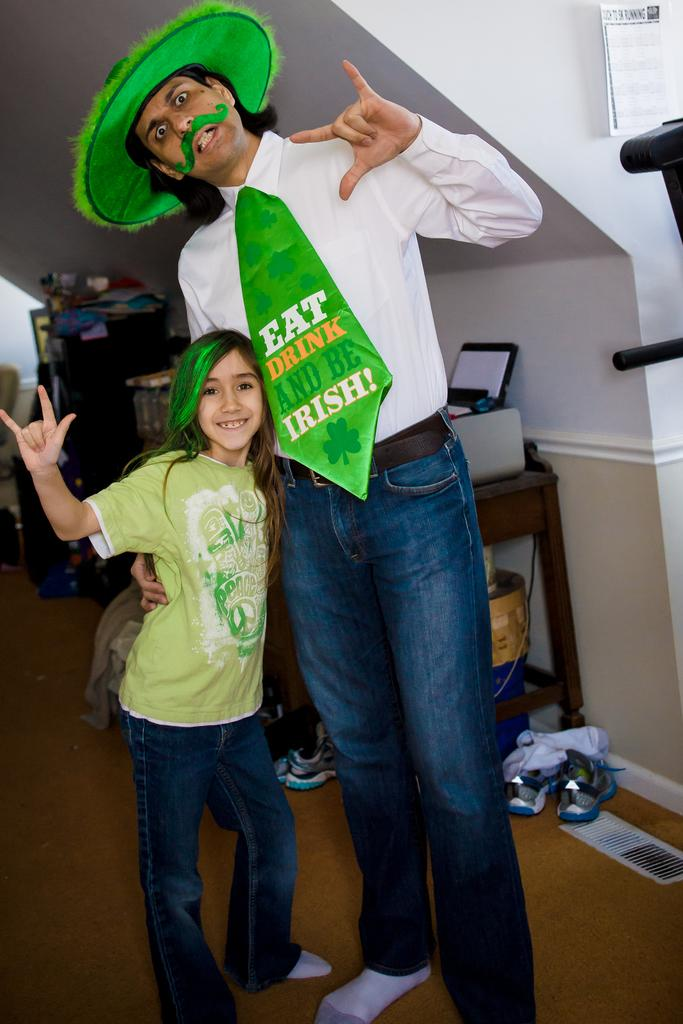Who is present in the image? There is a man and a little girl in the image. What is the man doing in the image? The man is standing in the image. What is the man wearing on his head? The man is wearing a green color hat. What is the man wearing around his neck? The man is wearing a tie. What is the little girl doing in the image? The little girl is smiling in the image. What color is the little girl's t-shirt? The little girl is wearing a green color t-shirt. What color are the little girl's trousers? The little girl is wearing blue color trousers. What type of spark can be seen coming from the man's tie? There is no spark present in the image. 